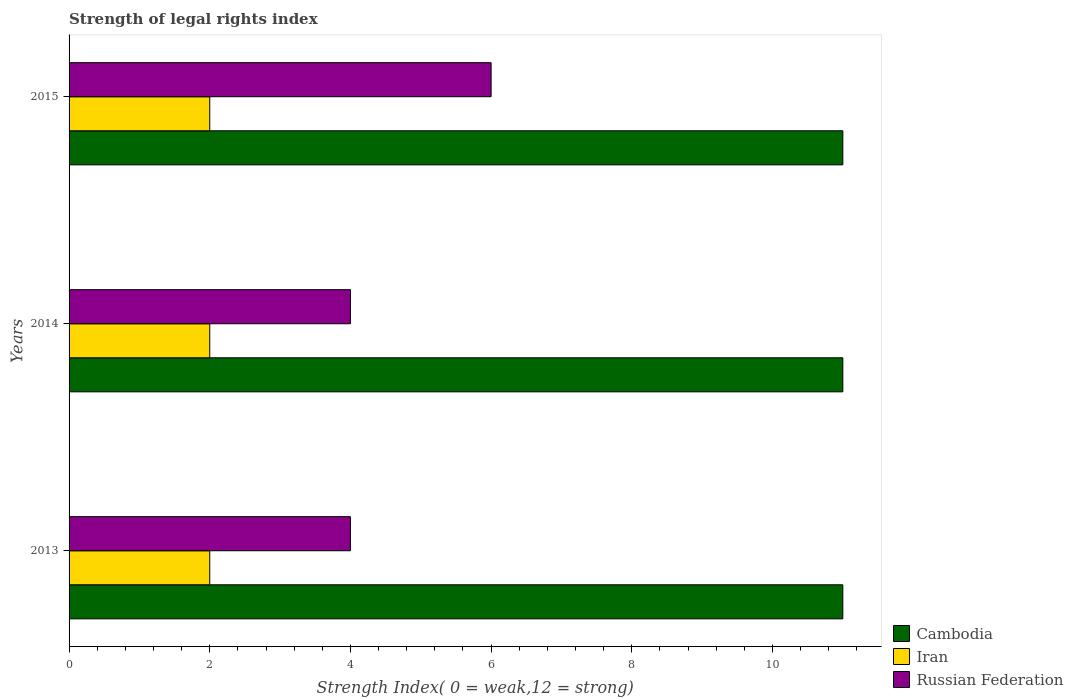How many different coloured bars are there?
Provide a succinct answer. 3. How many groups of bars are there?
Provide a succinct answer. 3. How many bars are there on the 1st tick from the top?
Make the answer very short. 3. How many bars are there on the 2nd tick from the bottom?
Make the answer very short. 3. What is the label of the 2nd group of bars from the top?
Offer a very short reply. 2014. What is the strength index in Iran in 2014?
Give a very brief answer. 2. Across all years, what is the maximum strength index in Cambodia?
Your answer should be very brief. 11. Across all years, what is the minimum strength index in Cambodia?
Offer a terse response. 11. In which year was the strength index in Russian Federation maximum?
Give a very brief answer. 2015. What is the difference between the strength index in Cambodia in 2013 and the strength index in Iran in 2015?
Your answer should be very brief. 9. What is the average strength index in Cambodia per year?
Provide a succinct answer. 11. In the year 2013, what is the difference between the strength index in Iran and strength index in Cambodia?
Give a very brief answer. -9. What is the ratio of the strength index in Iran in 2014 to that in 2015?
Your answer should be very brief. 1. What is the difference between the highest and the lowest strength index in Russian Federation?
Provide a short and direct response. 2. What does the 1st bar from the top in 2015 represents?
Your response must be concise. Russian Federation. What does the 1st bar from the bottom in 2013 represents?
Keep it short and to the point. Cambodia. Is it the case that in every year, the sum of the strength index in Russian Federation and strength index in Iran is greater than the strength index in Cambodia?
Your response must be concise. No. How many bars are there?
Your answer should be very brief. 9. What is the difference between two consecutive major ticks on the X-axis?
Make the answer very short. 2. Are the values on the major ticks of X-axis written in scientific E-notation?
Give a very brief answer. No. Does the graph contain any zero values?
Offer a very short reply. No. Does the graph contain grids?
Your answer should be very brief. No. What is the title of the graph?
Offer a terse response. Strength of legal rights index. Does "United Kingdom" appear as one of the legend labels in the graph?
Ensure brevity in your answer.  No. What is the label or title of the X-axis?
Give a very brief answer. Strength Index( 0 = weak,12 = strong). What is the Strength Index( 0 = weak,12 = strong) in Russian Federation in 2013?
Provide a succinct answer. 4. What is the Strength Index( 0 = weak,12 = strong) of Cambodia in 2014?
Give a very brief answer. 11. What is the Strength Index( 0 = weak,12 = strong) of Iran in 2014?
Offer a terse response. 2. What is the Strength Index( 0 = weak,12 = strong) of Russian Federation in 2014?
Provide a short and direct response. 4. What is the Strength Index( 0 = weak,12 = strong) in Russian Federation in 2015?
Offer a terse response. 6. Across all years, what is the maximum Strength Index( 0 = weak,12 = strong) of Cambodia?
Provide a succinct answer. 11. Across all years, what is the minimum Strength Index( 0 = weak,12 = strong) in Iran?
Make the answer very short. 2. Across all years, what is the minimum Strength Index( 0 = weak,12 = strong) in Russian Federation?
Give a very brief answer. 4. What is the total Strength Index( 0 = weak,12 = strong) of Iran in the graph?
Your answer should be very brief. 6. What is the total Strength Index( 0 = weak,12 = strong) in Russian Federation in the graph?
Provide a succinct answer. 14. What is the difference between the Strength Index( 0 = weak,12 = strong) of Cambodia in 2013 and that in 2014?
Your answer should be very brief. 0. What is the difference between the Strength Index( 0 = weak,12 = strong) in Cambodia in 2013 and that in 2015?
Provide a succinct answer. 0. What is the difference between the Strength Index( 0 = weak,12 = strong) in Iran in 2013 and that in 2015?
Your answer should be compact. 0. What is the difference between the Strength Index( 0 = weak,12 = strong) in Russian Federation in 2013 and that in 2015?
Keep it short and to the point. -2. What is the difference between the Strength Index( 0 = weak,12 = strong) in Cambodia in 2014 and that in 2015?
Provide a short and direct response. 0. What is the difference between the Strength Index( 0 = weak,12 = strong) in Iran in 2014 and that in 2015?
Keep it short and to the point. 0. What is the difference between the Strength Index( 0 = weak,12 = strong) in Cambodia in 2013 and the Strength Index( 0 = weak,12 = strong) in Iran in 2014?
Ensure brevity in your answer.  9. What is the difference between the Strength Index( 0 = weak,12 = strong) in Cambodia in 2013 and the Strength Index( 0 = weak,12 = strong) in Russian Federation in 2014?
Your response must be concise. 7. What is the difference between the Strength Index( 0 = weak,12 = strong) of Cambodia in 2013 and the Strength Index( 0 = weak,12 = strong) of Iran in 2015?
Your answer should be very brief. 9. What is the difference between the Strength Index( 0 = weak,12 = strong) in Cambodia in 2013 and the Strength Index( 0 = weak,12 = strong) in Russian Federation in 2015?
Your answer should be compact. 5. What is the difference between the Strength Index( 0 = weak,12 = strong) of Iran in 2013 and the Strength Index( 0 = weak,12 = strong) of Russian Federation in 2015?
Ensure brevity in your answer.  -4. What is the difference between the Strength Index( 0 = weak,12 = strong) of Cambodia in 2014 and the Strength Index( 0 = weak,12 = strong) of Russian Federation in 2015?
Your response must be concise. 5. What is the average Strength Index( 0 = weak,12 = strong) of Russian Federation per year?
Provide a short and direct response. 4.67. In the year 2013, what is the difference between the Strength Index( 0 = weak,12 = strong) in Iran and Strength Index( 0 = weak,12 = strong) in Russian Federation?
Your answer should be very brief. -2. In the year 2014, what is the difference between the Strength Index( 0 = weak,12 = strong) of Cambodia and Strength Index( 0 = weak,12 = strong) of Russian Federation?
Give a very brief answer. 7. In the year 2015, what is the difference between the Strength Index( 0 = weak,12 = strong) in Cambodia and Strength Index( 0 = weak,12 = strong) in Russian Federation?
Offer a very short reply. 5. What is the ratio of the Strength Index( 0 = weak,12 = strong) of Cambodia in 2013 to that in 2014?
Give a very brief answer. 1. What is the ratio of the Strength Index( 0 = weak,12 = strong) of Iran in 2013 to that in 2015?
Provide a short and direct response. 1. What is the ratio of the Strength Index( 0 = weak,12 = strong) in Russian Federation in 2013 to that in 2015?
Offer a terse response. 0.67. What is the ratio of the Strength Index( 0 = weak,12 = strong) of Iran in 2014 to that in 2015?
Make the answer very short. 1. What is the ratio of the Strength Index( 0 = weak,12 = strong) in Russian Federation in 2014 to that in 2015?
Make the answer very short. 0.67. What is the difference between the highest and the second highest Strength Index( 0 = weak,12 = strong) of Iran?
Keep it short and to the point. 0. What is the difference between the highest and the lowest Strength Index( 0 = weak,12 = strong) of Russian Federation?
Offer a terse response. 2. 